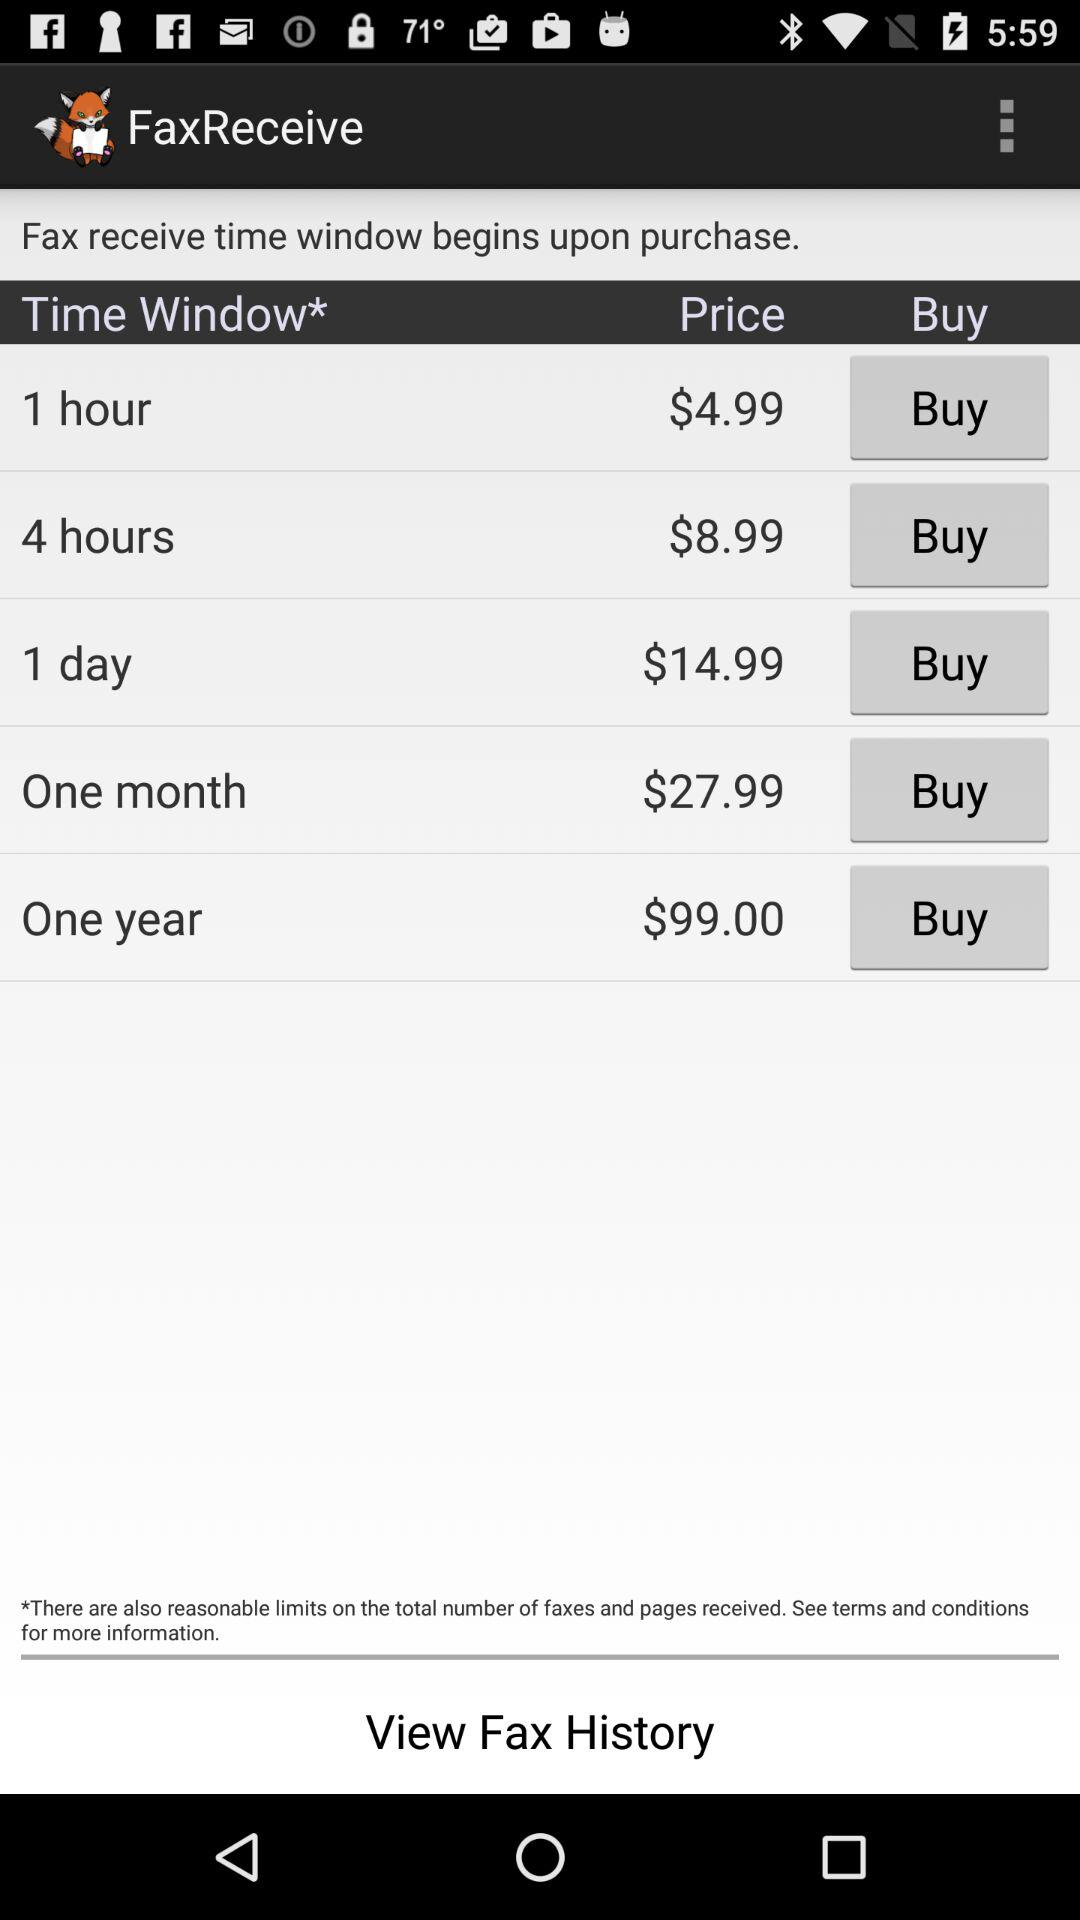At the price of $27.99, how much of a "Time Window" do we receive? The time window is "One month". 